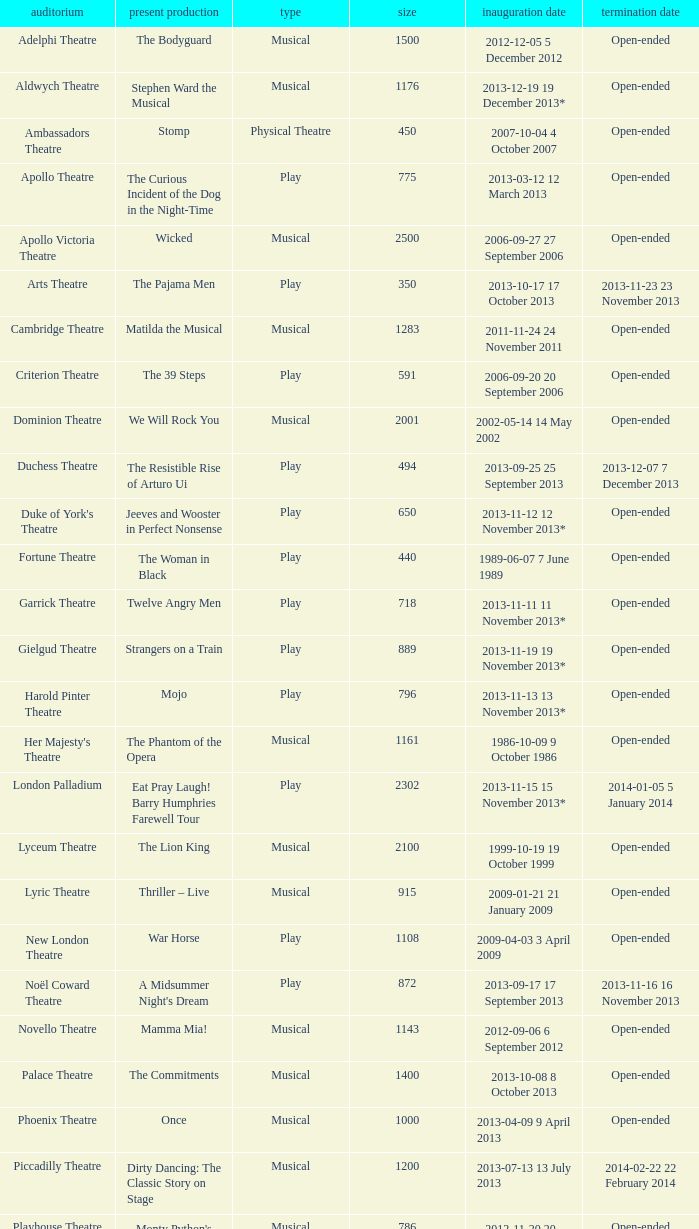Which starting date can accommodate 100 people? 2013-11-01 1 November 2013. 